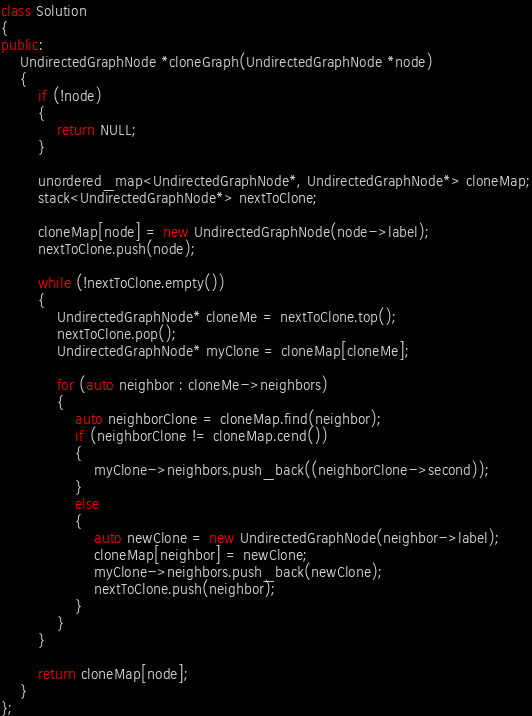Convert code to text. <code><loc_0><loc_0><loc_500><loc_500><_C++_>class Solution
{
public:
    UndirectedGraphNode *cloneGraph(UndirectedGraphNode *node)
    {
        if (!node)
        {
            return NULL;
        }

        unordered_map<UndirectedGraphNode*, UndirectedGraphNode*> cloneMap;
        stack<UndirectedGraphNode*> nextToClone;

        cloneMap[node] = new UndirectedGraphNode(node->label);
        nextToClone.push(node);

        while (!nextToClone.empty())
        {
            UndirectedGraphNode* cloneMe = nextToClone.top();
            nextToClone.pop();
            UndirectedGraphNode* myClone = cloneMap[cloneMe];

            for (auto neighbor : cloneMe->neighbors)
            {
                auto neighborClone = cloneMap.find(neighbor);
                if (neighborClone != cloneMap.cend())
                {
                    myClone->neighbors.push_back((neighborClone->second));
                }
                else
                {
                    auto newClone = new UndirectedGraphNode(neighbor->label);
                    cloneMap[neighbor] = newClone;
                    myClone->neighbors.push_back(newClone);
                    nextToClone.push(neighbor);
                }
            }
        }

        return cloneMap[node];
    }
};
</code> 